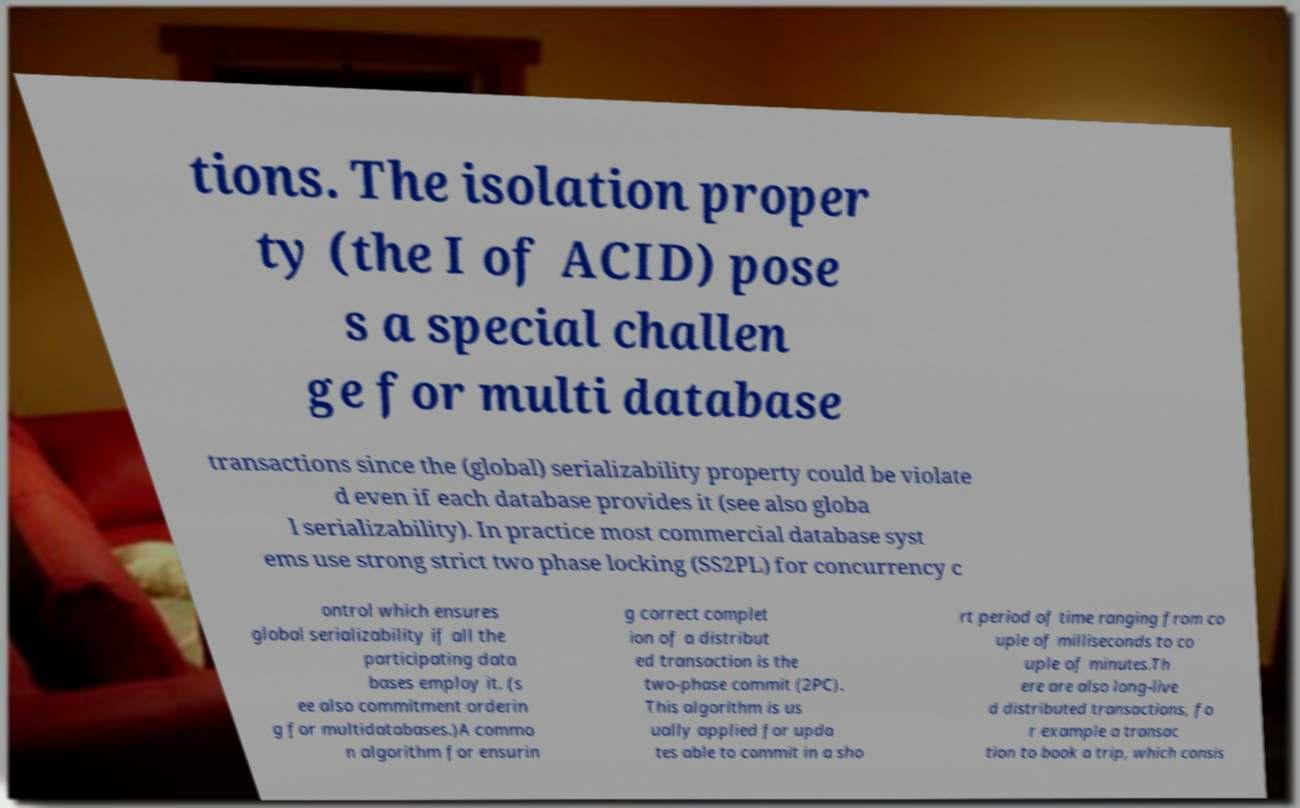Can you accurately transcribe the text from the provided image for me? tions. The isolation proper ty (the I of ACID) pose s a special challen ge for multi database transactions since the (global) serializability property could be violate d even if each database provides it (see also globa l serializability). In practice most commercial database syst ems use strong strict two phase locking (SS2PL) for concurrency c ontrol which ensures global serializability if all the participating data bases employ it. (s ee also commitment orderin g for multidatabases.)A commo n algorithm for ensurin g correct complet ion of a distribut ed transaction is the two-phase commit (2PC). This algorithm is us ually applied for upda tes able to commit in a sho rt period of time ranging from co uple of milliseconds to co uple of minutes.Th ere are also long-live d distributed transactions, fo r example a transac tion to book a trip, which consis 